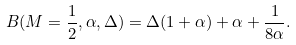Convert formula to latex. <formula><loc_0><loc_0><loc_500><loc_500>B ( M = \frac { 1 } { 2 } , \alpha , \Delta ) = \Delta ( 1 + \alpha ) + \alpha + \frac { 1 } { 8 \alpha } .</formula> 